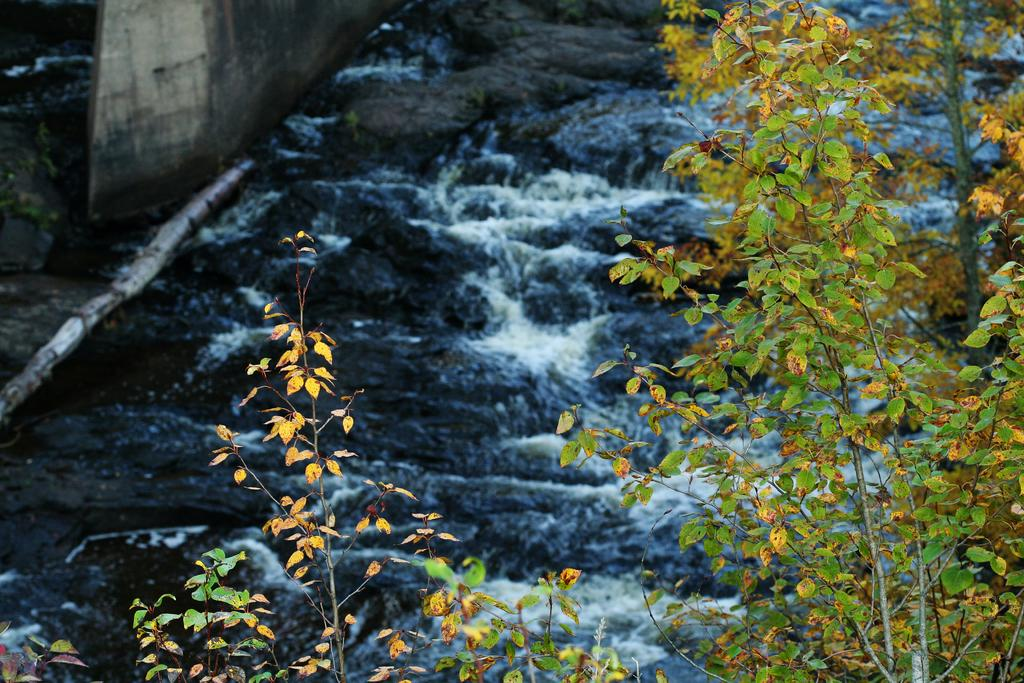What is happening to the water in the image? The water is flowing on rocks in the image. What can be seen to the right of the water in the image? There is a small plant to the right in the image. What is located to the left of the water in the image? There is a wall to the left in the image. What is at the bottom of the image? There are rocks at the bottom in the image. What type of chin is visible on the rocks in the image? There is no chin present in the image; it features water flowing on rocks. What type of furniture can be seen in the image? There is no furniture present in the image. 